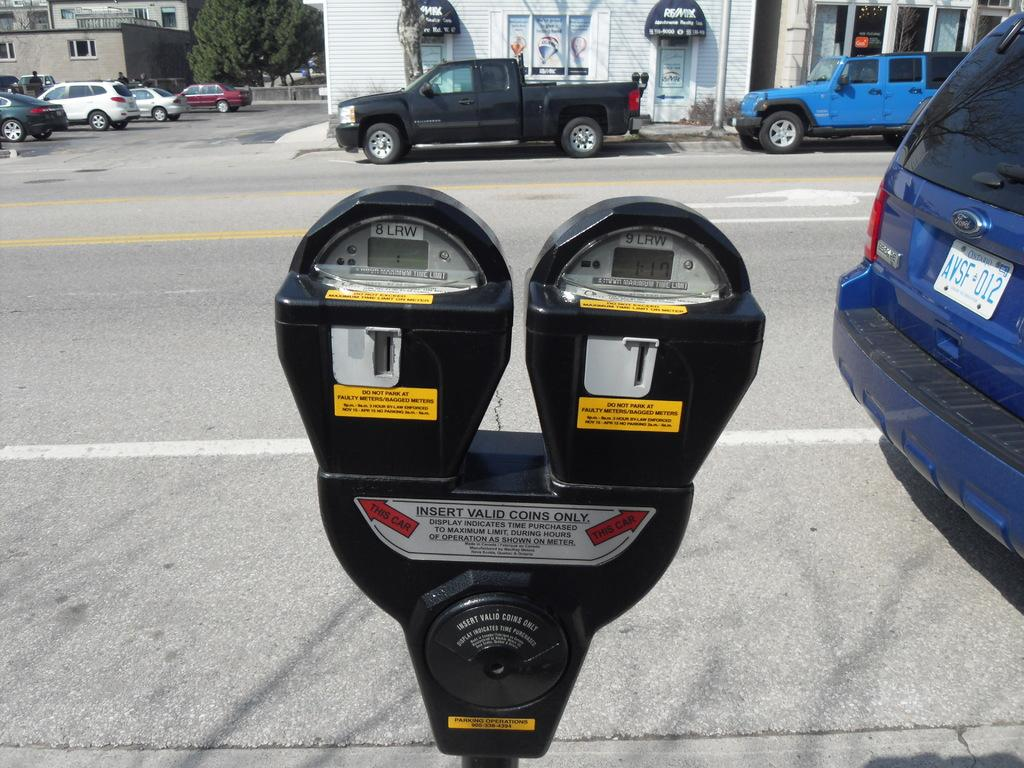Provide a one-sentence caption for the provided image. A blue van with Ontario license plates is parked near a parking meter. 